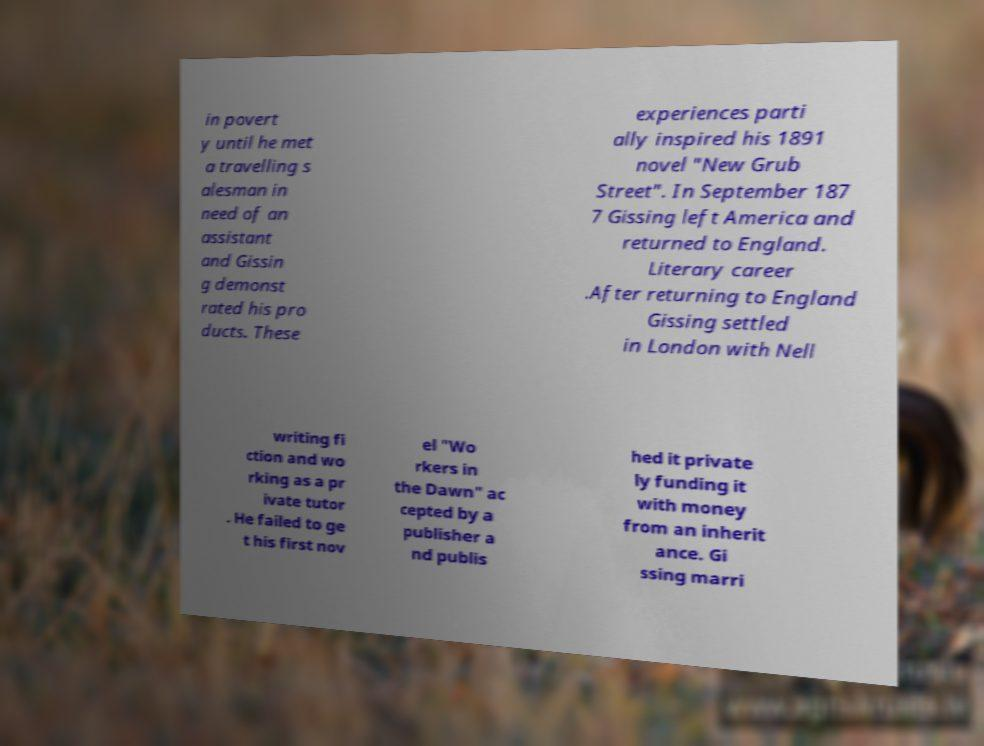There's text embedded in this image that I need extracted. Can you transcribe it verbatim? in povert y until he met a travelling s alesman in need of an assistant and Gissin g demonst rated his pro ducts. These experiences parti ally inspired his 1891 novel "New Grub Street". In September 187 7 Gissing left America and returned to England. Literary career .After returning to England Gissing settled in London with Nell writing fi ction and wo rking as a pr ivate tutor . He failed to ge t his first nov el "Wo rkers in the Dawn" ac cepted by a publisher a nd publis hed it private ly funding it with money from an inherit ance. Gi ssing marri 